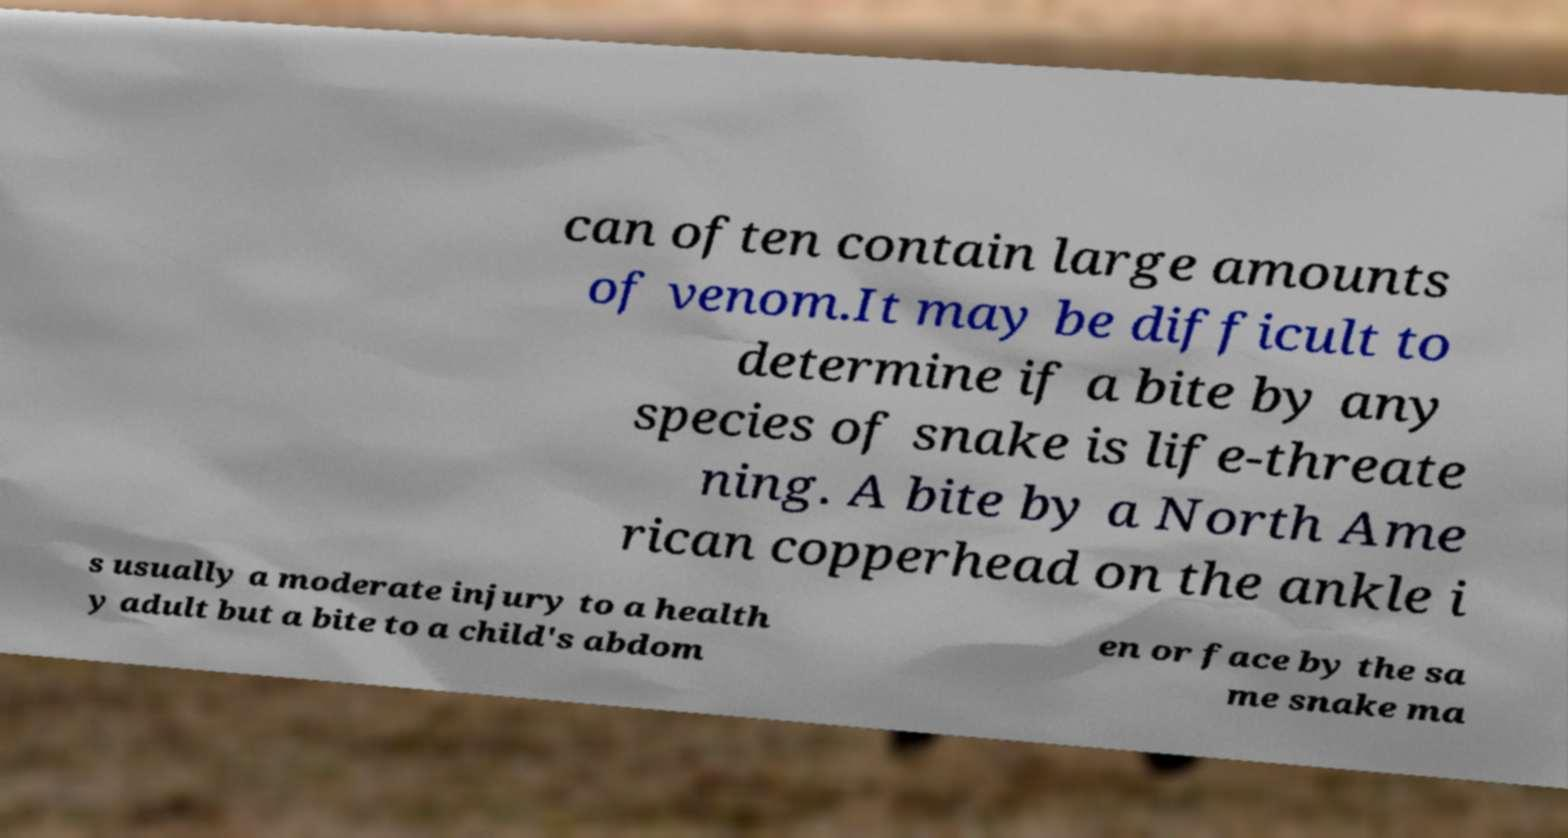What messages or text are displayed in this image? I need them in a readable, typed format. can often contain large amounts of venom.It may be difficult to determine if a bite by any species of snake is life-threate ning. A bite by a North Ame rican copperhead on the ankle i s usually a moderate injury to a health y adult but a bite to a child's abdom en or face by the sa me snake ma 